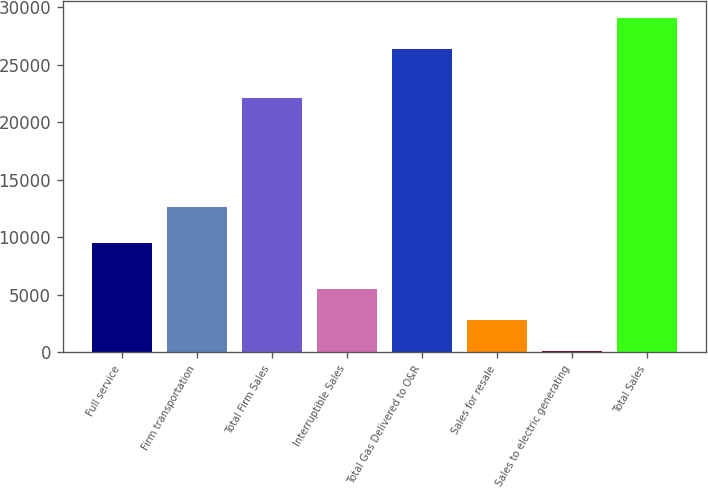<chart> <loc_0><loc_0><loc_500><loc_500><bar_chart><fcel>Full service<fcel>Firm transportation<fcel>Total Firm Sales<fcel>Interruptible Sales<fcel>Total Gas Delivered to O&R<fcel>Sales for resale<fcel>Sales to electric generating<fcel>Total Sales<nl><fcel>9529<fcel>12592<fcel>22121<fcel>5527<fcel>26337<fcel>2798.5<fcel>70<fcel>29065.5<nl></chart> 